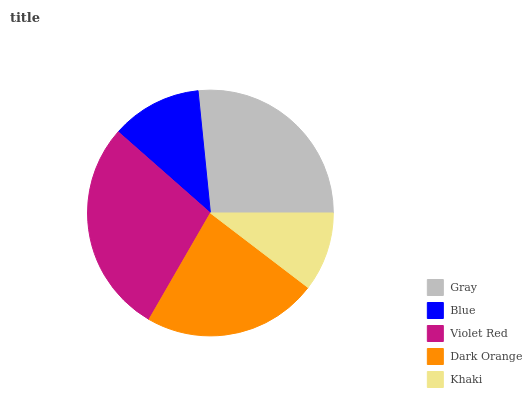Is Khaki the minimum?
Answer yes or no. Yes. Is Violet Red the maximum?
Answer yes or no. Yes. Is Blue the minimum?
Answer yes or no. No. Is Blue the maximum?
Answer yes or no. No. Is Gray greater than Blue?
Answer yes or no. Yes. Is Blue less than Gray?
Answer yes or no. Yes. Is Blue greater than Gray?
Answer yes or no. No. Is Gray less than Blue?
Answer yes or no. No. Is Dark Orange the high median?
Answer yes or no. Yes. Is Dark Orange the low median?
Answer yes or no. Yes. Is Gray the high median?
Answer yes or no. No. Is Blue the low median?
Answer yes or no. No. 